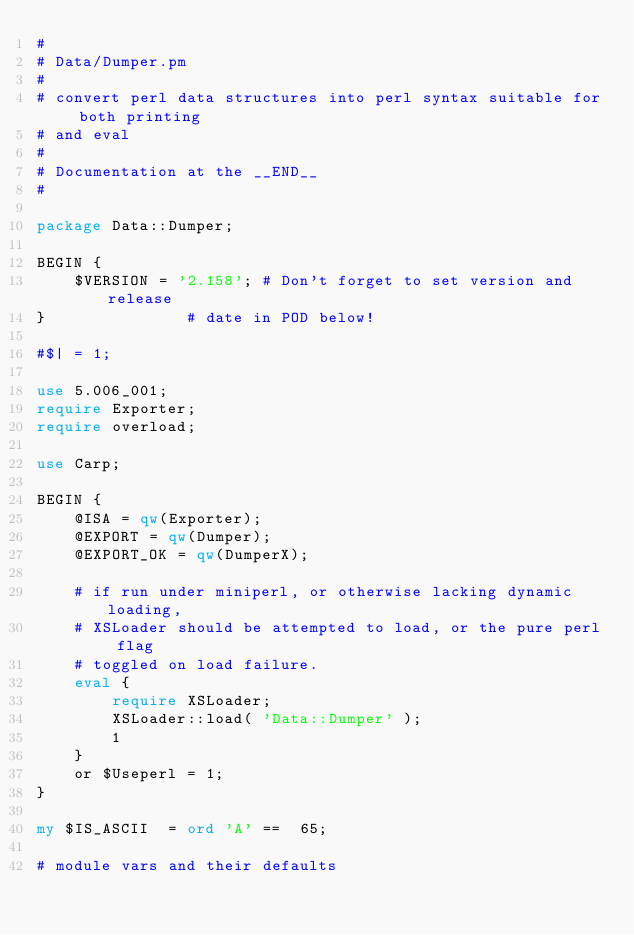Convert code to text. <code><loc_0><loc_0><loc_500><loc_500><_Perl_>#
# Data/Dumper.pm
#
# convert perl data structures into perl syntax suitable for both printing
# and eval
#
# Documentation at the __END__
#

package Data::Dumper;

BEGIN {
    $VERSION = '2.158'; # Don't forget to set version and release
}               # date in POD below!

#$| = 1;

use 5.006_001;
require Exporter;
require overload;

use Carp;

BEGIN {
    @ISA = qw(Exporter);
    @EXPORT = qw(Dumper);
    @EXPORT_OK = qw(DumperX);

    # if run under miniperl, or otherwise lacking dynamic loading,
    # XSLoader should be attempted to load, or the pure perl flag
    # toggled on load failure.
    eval {
        require XSLoader;
        XSLoader::load( 'Data::Dumper' );
        1
    }
    or $Useperl = 1;
}

my $IS_ASCII  = ord 'A' ==  65;

# module vars and their defaults</code> 